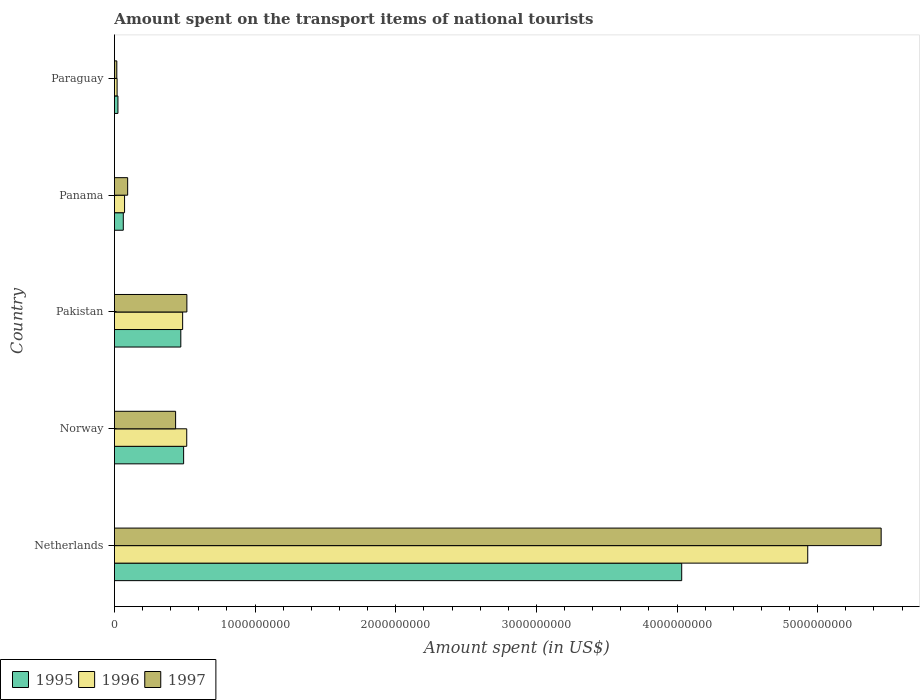How many different coloured bars are there?
Your answer should be compact. 3. How many groups of bars are there?
Give a very brief answer. 5. Are the number of bars per tick equal to the number of legend labels?
Your answer should be very brief. Yes. How many bars are there on the 3rd tick from the bottom?
Offer a very short reply. 3. What is the label of the 5th group of bars from the top?
Offer a very short reply. Netherlands. In how many cases, is the number of bars for a given country not equal to the number of legend labels?
Provide a short and direct response. 0. What is the amount spent on the transport items of national tourists in 1995 in Norway?
Provide a short and direct response. 4.92e+08. Across all countries, what is the maximum amount spent on the transport items of national tourists in 1996?
Your answer should be compact. 4.93e+09. Across all countries, what is the minimum amount spent on the transport items of national tourists in 1996?
Provide a succinct answer. 1.90e+07. In which country was the amount spent on the transport items of national tourists in 1996 minimum?
Keep it short and to the point. Paraguay. What is the total amount spent on the transport items of national tourists in 1996 in the graph?
Make the answer very short. 6.02e+09. What is the difference between the amount spent on the transport items of national tourists in 1995 in Pakistan and that in Panama?
Provide a short and direct response. 4.09e+08. What is the difference between the amount spent on the transport items of national tourists in 1995 in Panama and the amount spent on the transport items of national tourists in 1996 in Pakistan?
Your response must be concise. -4.22e+08. What is the average amount spent on the transport items of national tourists in 1996 per country?
Ensure brevity in your answer.  1.20e+09. What is the difference between the amount spent on the transport items of national tourists in 1997 and amount spent on the transport items of national tourists in 1995 in Panama?
Your answer should be very brief. 3.10e+07. What is the ratio of the amount spent on the transport items of national tourists in 1995 in Norway to that in Paraguay?
Keep it short and to the point. 19.68. Is the difference between the amount spent on the transport items of national tourists in 1997 in Pakistan and Panama greater than the difference between the amount spent on the transport items of national tourists in 1995 in Pakistan and Panama?
Offer a terse response. Yes. What is the difference between the highest and the second highest amount spent on the transport items of national tourists in 1996?
Your response must be concise. 4.42e+09. What is the difference between the highest and the lowest amount spent on the transport items of national tourists in 1997?
Keep it short and to the point. 5.43e+09. In how many countries, is the amount spent on the transport items of national tourists in 1996 greater than the average amount spent on the transport items of national tourists in 1996 taken over all countries?
Your answer should be compact. 1. Is the sum of the amount spent on the transport items of national tourists in 1995 in Norway and Paraguay greater than the maximum amount spent on the transport items of national tourists in 1997 across all countries?
Offer a very short reply. No. What does the 2nd bar from the top in Paraguay represents?
Offer a terse response. 1996. Is it the case that in every country, the sum of the amount spent on the transport items of national tourists in 1997 and amount spent on the transport items of national tourists in 1995 is greater than the amount spent on the transport items of national tourists in 1996?
Keep it short and to the point. Yes. How many bars are there?
Provide a succinct answer. 15. Are the values on the major ticks of X-axis written in scientific E-notation?
Your answer should be compact. No. Where does the legend appear in the graph?
Your answer should be very brief. Bottom left. How many legend labels are there?
Give a very brief answer. 3. What is the title of the graph?
Ensure brevity in your answer.  Amount spent on the transport items of national tourists. What is the label or title of the X-axis?
Ensure brevity in your answer.  Amount spent (in US$). What is the Amount spent (in US$) in 1995 in Netherlands?
Your answer should be very brief. 4.03e+09. What is the Amount spent (in US$) of 1996 in Netherlands?
Your answer should be very brief. 4.93e+09. What is the Amount spent (in US$) in 1997 in Netherlands?
Ensure brevity in your answer.  5.45e+09. What is the Amount spent (in US$) of 1995 in Norway?
Your answer should be very brief. 4.92e+08. What is the Amount spent (in US$) of 1996 in Norway?
Your answer should be compact. 5.14e+08. What is the Amount spent (in US$) of 1997 in Norway?
Provide a short and direct response. 4.35e+08. What is the Amount spent (in US$) of 1995 in Pakistan?
Give a very brief answer. 4.72e+08. What is the Amount spent (in US$) in 1996 in Pakistan?
Provide a short and direct response. 4.85e+08. What is the Amount spent (in US$) of 1997 in Pakistan?
Offer a terse response. 5.15e+08. What is the Amount spent (in US$) in 1995 in Panama?
Make the answer very short. 6.30e+07. What is the Amount spent (in US$) in 1996 in Panama?
Provide a short and direct response. 7.20e+07. What is the Amount spent (in US$) of 1997 in Panama?
Offer a terse response. 9.40e+07. What is the Amount spent (in US$) of 1995 in Paraguay?
Provide a succinct answer. 2.50e+07. What is the Amount spent (in US$) of 1996 in Paraguay?
Provide a succinct answer. 1.90e+07. What is the Amount spent (in US$) of 1997 in Paraguay?
Provide a succinct answer. 1.70e+07. Across all countries, what is the maximum Amount spent (in US$) of 1995?
Keep it short and to the point. 4.03e+09. Across all countries, what is the maximum Amount spent (in US$) in 1996?
Your answer should be very brief. 4.93e+09. Across all countries, what is the maximum Amount spent (in US$) in 1997?
Your answer should be very brief. 5.45e+09. Across all countries, what is the minimum Amount spent (in US$) in 1995?
Your answer should be very brief. 2.50e+07. Across all countries, what is the minimum Amount spent (in US$) in 1996?
Ensure brevity in your answer.  1.90e+07. Across all countries, what is the minimum Amount spent (in US$) of 1997?
Your answer should be very brief. 1.70e+07. What is the total Amount spent (in US$) of 1995 in the graph?
Your answer should be very brief. 5.08e+09. What is the total Amount spent (in US$) of 1996 in the graph?
Your answer should be compact. 6.02e+09. What is the total Amount spent (in US$) in 1997 in the graph?
Provide a short and direct response. 6.51e+09. What is the difference between the Amount spent (in US$) of 1995 in Netherlands and that in Norway?
Provide a succinct answer. 3.54e+09. What is the difference between the Amount spent (in US$) of 1996 in Netherlands and that in Norway?
Provide a short and direct response. 4.42e+09. What is the difference between the Amount spent (in US$) in 1997 in Netherlands and that in Norway?
Offer a very short reply. 5.02e+09. What is the difference between the Amount spent (in US$) in 1995 in Netherlands and that in Pakistan?
Make the answer very short. 3.56e+09. What is the difference between the Amount spent (in US$) in 1996 in Netherlands and that in Pakistan?
Give a very brief answer. 4.44e+09. What is the difference between the Amount spent (in US$) of 1997 in Netherlands and that in Pakistan?
Offer a terse response. 4.94e+09. What is the difference between the Amount spent (in US$) of 1995 in Netherlands and that in Panama?
Offer a very short reply. 3.97e+09. What is the difference between the Amount spent (in US$) in 1996 in Netherlands and that in Panama?
Your response must be concise. 4.86e+09. What is the difference between the Amount spent (in US$) of 1997 in Netherlands and that in Panama?
Provide a short and direct response. 5.36e+09. What is the difference between the Amount spent (in US$) in 1995 in Netherlands and that in Paraguay?
Provide a succinct answer. 4.01e+09. What is the difference between the Amount spent (in US$) in 1996 in Netherlands and that in Paraguay?
Make the answer very short. 4.91e+09. What is the difference between the Amount spent (in US$) in 1997 in Netherlands and that in Paraguay?
Keep it short and to the point. 5.43e+09. What is the difference between the Amount spent (in US$) of 1995 in Norway and that in Pakistan?
Provide a succinct answer. 2.00e+07. What is the difference between the Amount spent (in US$) in 1996 in Norway and that in Pakistan?
Ensure brevity in your answer.  2.90e+07. What is the difference between the Amount spent (in US$) of 1997 in Norway and that in Pakistan?
Your response must be concise. -8.00e+07. What is the difference between the Amount spent (in US$) in 1995 in Norway and that in Panama?
Provide a succinct answer. 4.29e+08. What is the difference between the Amount spent (in US$) in 1996 in Norway and that in Panama?
Ensure brevity in your answer.  4.42e+08. What is the difference between the Amount spent (in US$) in 1997 in Norway and that in Panama?
Ensure brevity in your answer.  3.41e+08. What is the difference between the Amount spent (in US$) of 1995 in Norway and that in Paraguay?
Give a very brief answer. 4.67e+08. What is the difference between the Amount spent (in US$) in 1996 in Norway and that in Paraguay?
Offer a terse response. 4.95e+08. What is the difference between the Amount spent (in US$) in 1997 in Norway and that in Paraguay?
Provide a short and direct response. 4.18e+08. What is the difference between the Amount spent (in US$) in 1995 in Pakistan and that in Panama?
Offer a very short reply. 4.09e+08. What is the difference between the Amount spent (in US$) in 1996 in Pakistan and that in Panama?
Give a very brief answer. 4.13e+08. What is the difference between the Amount spent (in US$) of 1997 in Pakistan and that in Panama?
Your response must be concise. 4.21e+08. What is the difference between the Amount spent (in US$) of 1995 in Pakistan and that in Paraguay?
Your answer should be very brief. 4.47e+08. What is the difference between the Amount spent (in US$) in 1996 in Pakistan and that in Paraguay?
Your answer should be very brief. 4.66e+08. What is the difference between the Amount spent (in US$) in 1997 in Pakistan and that in Paraguay?
Provide a short and direct response. 4.98e+08. What is the difference between the Amount spent (in US$) of 1995 in Panama and that in Paraguay?
Offer a very short reply. 3.80e+07. What is the difference between the Amount spent (in US$) in 1996 in Panama and that in Paraguay?
Your response must be concise. 5.30e+07. What is the difference between the Amount spent (in US$) in 1997 in Panama and that in Paraguay?
Ensure brevity in your answer.  7.70e+07. What is the difference between the Amount spent (in US$) in 1995 in Netherlands and the Amount spent (in US$) in 1996 in Norway?
Your answer should be compact. 3.52e+09. What is the difference between the Amount spent (in US$) in 1995 in Netherlands and the Amount spent (in US$) in 1997 in Norway?
Make the answer very short. 3.60e+09. What is the difference between the Amount spent (in US$) in 1996 in Netherlands and the Amount spent (in US$) in 1997 in Norway?
Ensure brevity in your answer.  4.49e+09. What is the difference between the Amount spent (in US$) of 1995 in Netherlands and the Amount spent (in US$) of 1996 in Pakistan?
Make the answer very short. 3.55e+09. What is the difference between the Amount spent (in US$) in 1995 in Netherlands and the Amount spent (in US$) in 1997 in Pakistan?
Offer a very short reply. 3.52e+09. What is the difference between the Amount spent (in US$) of 1996 in Netherlands and the Amount spent (in US$) of 1997 in Pakistan?
Keep it short and to the point. 4.41e+09. What is the difference between the Amount spent (in US$) of 1995 in Netherlands and the Amount spent (in US$) of 1996 in Panama?
Keep it short and to the point. 3.96e+09. What is the difference between the Amount spent (in US$) of 1995 in Netherlands and the Amount spent (in US$) of 1997 in Panama?
Provide a short and direct response. 3.94e+09. What is the difference between the Amount spent (in US$) of 1996 in Netherlands and the Amount spent (in US$) of 1997 in Panama?
Your answer should be very brief. 4.84e+09. What is the difference between the Amount spent (in US$) in 1995 in Netherlands and the Amount spent (in US$) in 1996 in Paraguay?
Offer a terse response. 4.01e+09. What is the difference between the Amount spent (in US$) of 1995 in Netherlands and the Amount spent (in US$) of 1997 in Paraguay?
Your response must be concise. 4.02e+09. What is the difference between the Amount spent (in US$) of 1996 in Netherlands and the Amount spent (in US$) of 1997 in Paraguay?
Offer a very short reply. 4.91e+09. What is the difference between the Amount spent (in US$) of 1995 in Norway and the Amount spent (in US$) of 1997 in Pakistan?
Give a very brief answer. -2.30e+07. What is the difference between the Amount spent (in US$) of 1995 in Norway and the Amount spent (in US$) of 1996 in Panama?
Your response must be concise. 4.20e+08. What is the difference between the Amount spent (in US$) in 1995 in Norway and the Amount spent (in US$) in 1997 in Panama?
Offer a terse response. 3.98e+08. What is the difference between the Amount spent (in US$) of 1996 in Norway and the Amount spent (in US$) of 1997 in Panama?
Give a very brief answer. 4.20e+08. What is the difference between the Amount spent (in US$) of 1995 in Norway and the Amount spent (in US$) of 1996 in Paraguay?
Provide a short and direct response. 4.73e+08. What is the difference between the Amount spent (in US$) in 1995 in Norway and the Amount spent (in US$) in 1997 in Paraguay?
Provide a short and direct response. 4.75e+08. What is the difference between the Amount spent (in US$) in 1996 in Norway and the Amount spent (in US$) in 1997 in Paraguay?
Give a very brief answer. 4.97e+08. What is the difference between the Amount spent (in US$) in 1995 in Pakistan and the Amount spent (in US$) in 1996 in Panama?
Ensure brevity in your answer.  4.00e+08. What is the difference between the Amount spent (in US$) in 1995 in Pakistan and the Amount spent (in US$) in 1997 in Panama?
Your answer should be compact. 3.78e+08. What is the difference between the Amount spent (in US$) of 1996 in Pakistan and the Amount spent (in US$) of 1997 in Panama?
Provide a succinct answer. 3.91e+08. What is the difference between the Amount spent (in US$) in 1995 in Pakistan and the Amount spent (in US$) in 1996 in Paraguay?
Offer a terse response. 4.53e+08. What is the difference between the Amount spent (in US$) in 1995 in Pakistan and the Amount spent (in US$) in 1997 in Paraguay?
Offer a very short reply. 4.55e+08. What is the difference between the Amount spent (in US$) of 1996 in Pakistan and the Amount spent (in US$) of 1997 in Paraguay?
Keep it short and to the point. 4.68e+08. What is the difference between the Amount spent (in US$) of 1995 in Panama and the Amount spent (in US$) of 1996 in Paraguay?
Your answer should be compact. 4.40e+07. What is the difference between the Amount spent (in US$) of 1995 in Panama and the Amount spent (in US$) of 1997 in Paraguay?
Make the answer very short. 4.60e+07. What is the difference between the Amount spent (in US$) in 1996 in Panama and the Amount spent (in US$) in 1997 in Paraguay?
Your response must be concise. 5.50e+07. What is the average Amount spent (in US$) of 1995 per country?
Your answer should be very brief. 1.02e+09. What is the average Amount spent (in US$) in 1996 per country?
Ensure brevity in your answer.  1.20e+09. What is the average Amount spent (in US$) in 1997 per country?
Give a very brief answer. 1.30e+09. What is the difference between the Amount spent (in US$) of 1995 and Amount spent (in US$) of 1996 in Netherlands?
Your answer should be very brief. -8.96e+08. What is the difference between the Amount spent (in US$) in 1995 and Amount spent (in US$) in 1997 in Netherlands?
Make the answer very short. -1.42e+09. What is the difference between the Amount spent (in US$) in 1996 and Amount spent (in US$) in 1997 in Netherlands?
Make the answer very short. -5.22e+08. What is the difference between the Amount spent (in US$) of 1995 and Amount spent (in US$) of 1996 in Norway?
Give a very brief answer. -2.20e+07. What is the difference between the Amount spent (in US$) of 1995 and Amount spent (in US$) of 1997 in Norway?
Provide a succinct answer. 5.70e+07. What is the difference between the Amount spent (in US$) in 1996 and Amount spent (in US$) in 1997 in Norway?
Your response must be concise. 7.90e+07. What is the difference between the Amount spent (in US$) of 1995 and Amount spent (in US$) of 1996 in Pakistan?
Provide a short and direct response. -1.30e+07. What is the difference between the Amount spent (in US$) in 1995 and Amount spent (in US$) in 1997 in Pakistan?
Provide a short and direct response. -4.30e+07. What is the difference between the Amount spent (in US$) in 1996 and Amount spent (in US$) in 1997 in Pakistan?
Make the answer very short. -3.00e+07. What is the difference between the Amount spent (in US$) of 1995 and Amount spent (in US$) of 1996 in Panama?
Your answer should be compact. -9.00e+06. What is the difference between the Amount spent (in US$) of 1995 and Amount spent (in US$) of 1997 in Panama?
Give a very brief answer. -3.10e+07. What is the difference between the Amount spent (in US$) of 1996 and Amount spent (in US$) of 1997 in Panama?
Your answer should be very brief. -2.20e+07. What is the difference between the Amount spent (in US$) of 1995 and Amount spent (in US$) of 1996 in Paraguay?
Provide a succinct answer. 6.00e+06. What is the difference between the Amount spent (in US$) of 1995 and Amount spent (in US$) of 1997 in Paraguay?
Offer a very short reply. 8.00e+06. What is the difference between the Amount spent (in US$) of 1996 and Amount spent (in US$) of 1997 in Paraguay?
Provide a short and direct response. 2.00e+06. What is the ratio of the Amount spent (in US$) in 1995 in Netherlands to that in Norway?
Provide a succinct answer. 8.2. What is the ratio of the Amount spent (in US$) in 1996 in Netherlands to that in Norway?
Ensure brevity in your answer.  9.59. What is the ratio of the Amount spent (in US$) in 1997 in Netherlands to that in Norway?
Offer a terse response. 12.53. What is the ratio of the Amount spent (in US$) of 1995 in Netherlands to that in Pakistan?
Keep it short and to the point. 8.54. What is the ratio of the Amount spent (in US$) in 1996 in Netherlands to that in Pakistan?
Give a very brief answer. 10.16. What is the ratio of the Amount spent (in US$) in 1997 in Netherlands to that in Pakistan?
Provide a short and direct response. 10.58. What is the ratio of the Amount spent (in US$) of 1995 in Netherlands to that in Panama?
Provide a short and direct response. 64.02. What is the ratio of the Amount spent (in US$) of 1996 in Netherlands to that in Panama?
Offer a very short reply. 68.46. What is the ratio of the Amount spent (in US$) in 1997 in Netherlands to that in Panama?
Provide a short and direct response. 57.99. What is the ratio of the Amount spent (in US$) in 1995 in Netherlands to that in Paraguay?
Keep it short and to the point. 161.32. What is the ratio of the Amount spent (in US$) of 1996 in Netherlands to that in Paraguay?
Your answer should be compact. 259.42. What is the ratio of the Amount spent (in US$) in 1997 in Netherlands to that in Paraguay?
Provide a short and direct response. 320.65. What is the ratio of the Amount spent (in US$) of 1995 in Norway to that in Pakistan?
Offer a very short reply. 1.04. What is the ratio of the Amount spent (in US$) in 1996 in Norway to that in Pakistan?
Provide a short and direct response. 1.06. What is the ratio of the Amount spent (in US$) in 1997 in Norway to that in Pakistan?
Keep it short and to the point. 0.84. What is the ratio of the Amount spent (in US$) of 1995 in Norway to that in Panama?
Provide a succinct answer. 7.81. What is the ratio of the Amount spent (in US$) in 1996 in Norway to that in Panama?
Your answer should be very brief. 7.14. What is the ratio of the Amount spent (in US$) in 1997 in Norway to that in Panama?
Your answer should be very brief. 4.63. What is the ratio of the Amount spent (in US$) in 1995 in Norway to that in Paraguay?
Ensure brevity in your answer.  19.68. What is the ratio of the Amount spent (in US$) of 1996 in Norway to that in Paraguay?
Your answer should be very brief. 27.05. What is the ratio of the Amount spent (in US$) of 1997 in Norway to that in Paraguay?
Offer a very short reply. 25.59. What is the ratio of the Amount spent (in US$) in 1995 in Pakistan to that in Panama?
Provide a succinct answer. 7.49. What is the ratio of the Amount spent (in US$) of 1996 in Pakistan to that in Panama?
Your answer should be compact. 6.74. What is the ratio of the Amount spent (in US$) in 1997 in Pakistan to that in Panama?
Make the answer very short. 5.48. What is the ratio of the Amount spent (in US$) of 1995 in Pakistan to that in Paraguay?
Provide a short and direct response. 18.88. What is the ratio of the Amount spent (in US$) in 1996 in Pakistan to that in Paraguay?
Ensure brevity in your answer.  25.53. What is the ratio of the Amount spent (in US$) in 1997 in Pakistan to that in Paraguay?
Your answer should be very brief. 30.29. What is the ratio of the Amount spent (in US$) in 1995 in Panama to that in Paraguay?
Provide a succinct answer. 2.52. What is the ratio of the Amount spent (in US$) of 1996 in Panama to that in Paraguay?
Provide a short and direct response. 3.79. What is the ratio of the Amount spent (in US$) in 1997 in Panama to that in Paraguay?
Provide a succinct answer. 5.53. What is the difference between the highest and the second highest Amount spent (in US$) of 1995?
Make the answer very short. 3.54e+09. What is the difference between the highest and the second highest Amount spent (in US$) of 1996?
Provide a short and direct response. 4.42e+09. What is the difference between the highest and the second highest Amount spent (in US$) of 1997?
Your answer should be compact. 4.94e+09. What is the difference between the highest and the lowest Amount spent (in US$) in 1995?
Provide a short and direct response. 4.01e+09. What is the difference between the highest and the lowest Amount spent (in US$) in 1996?
Provide a short and direct response. 4.91e+09. What is the difference between the highest and the lowest Amount spent (in US$) in 1997?
Ensure brevity in your answer.  5.43e+09. 